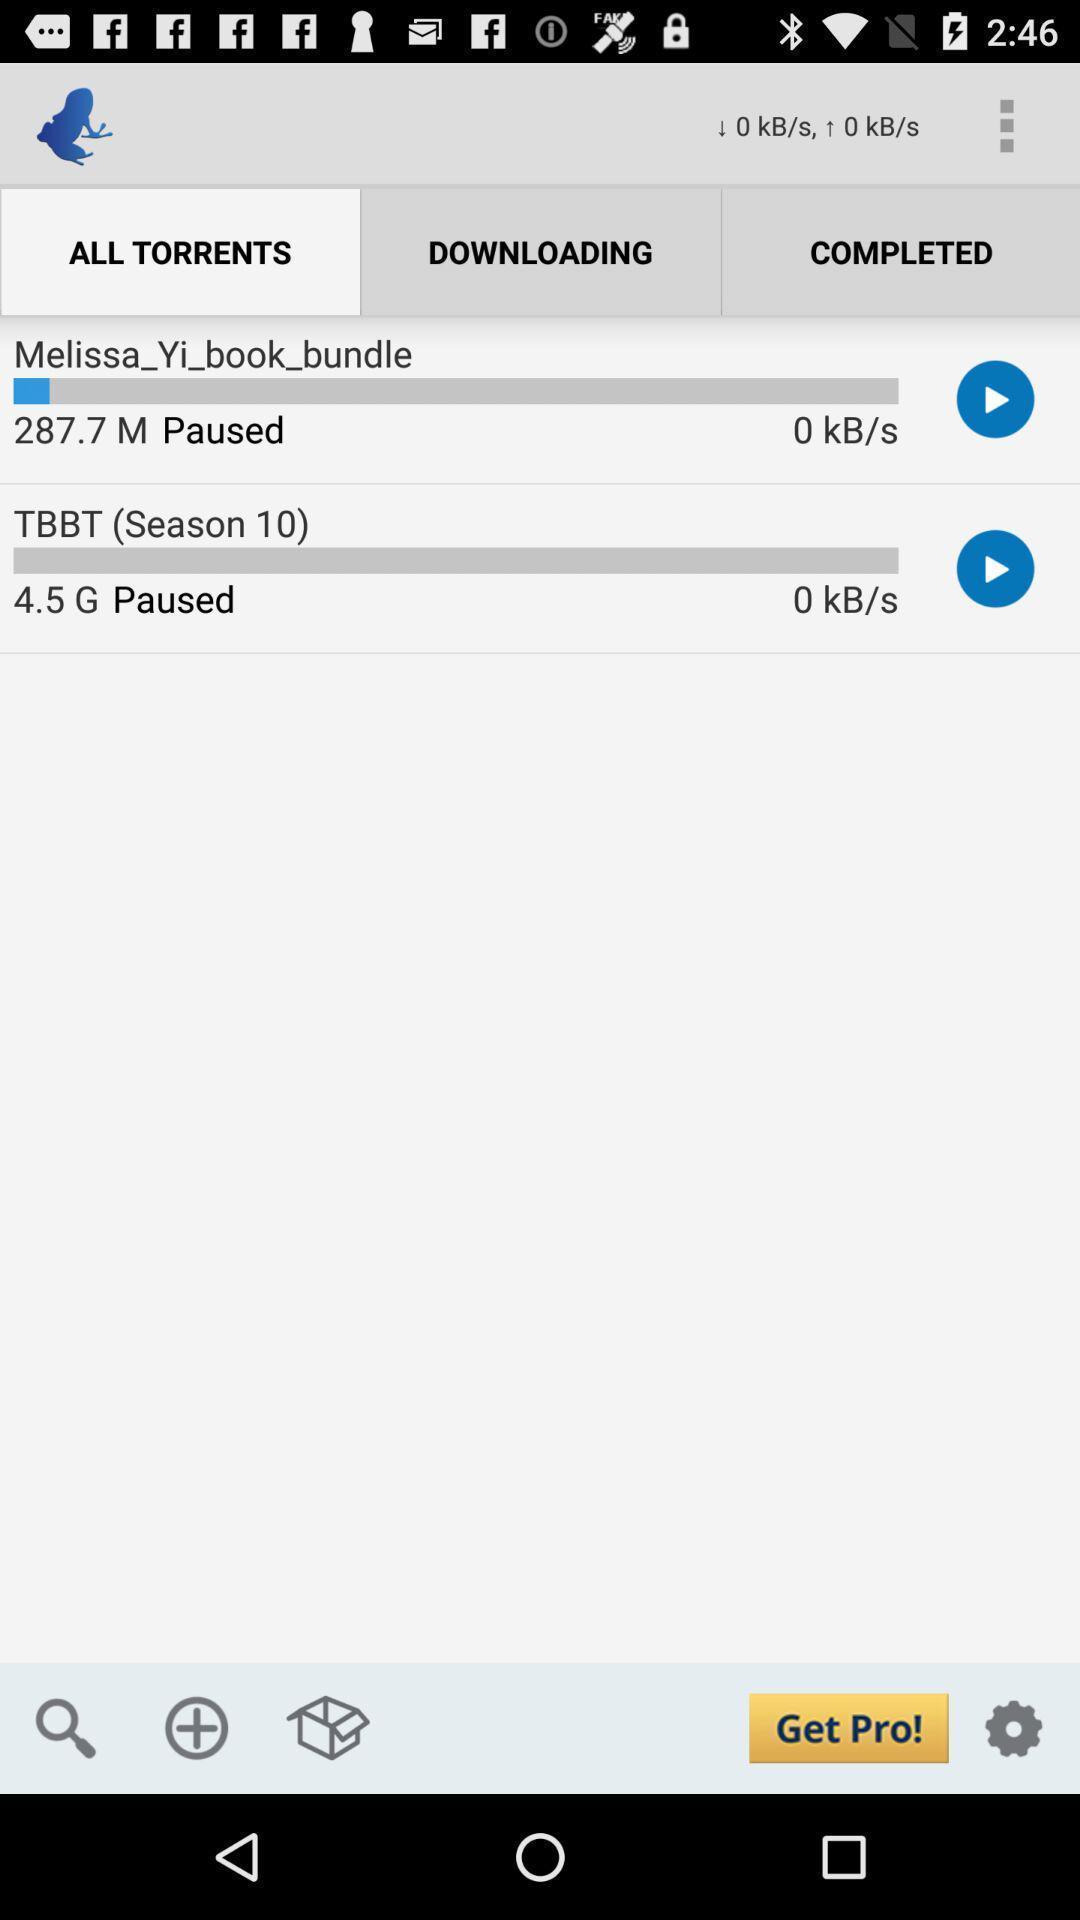Explain the elements present in this screenshot. Page displaying with downloading paused torrents. 